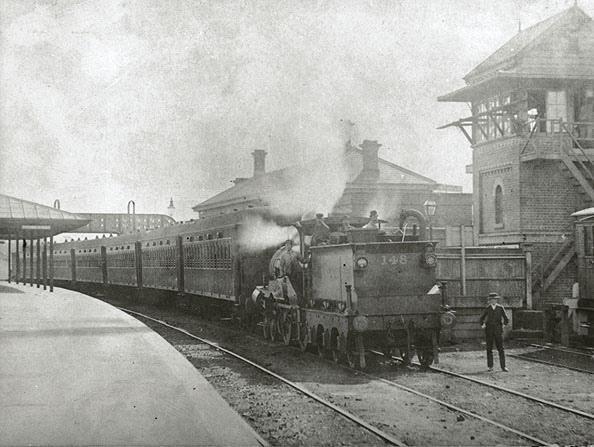How many hot dogs are on the plate?
Give a very brief answer. 0. 